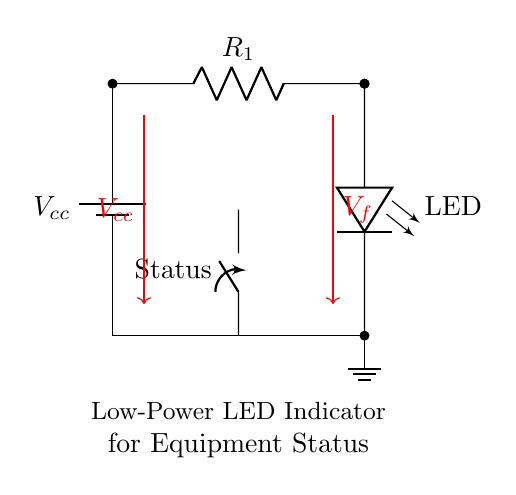What is the function of the LED in this circuit? The LED serves as an indicator for equipment status, illuminating when the circuit is active.
Answer: Indicator What component limits the current through the LED? The resistor connected in series with the LED limits the current to prevent damage to the LED.
Answer: Resistor What does the switch in this circuit represent? The switch represents a way to control whether the LED is lit or unlit by interrupting the circuit.
Answer: Status What is the voltage across the LED when it is turned on? The voltage across the LED, denoted as V_f, is typically around 2V for standard LEDs, depending on the type used.
Answer: V_f How does the current flow when the switch is closed? When the switch is closed, current flows from the battery to the resistor, then through the LED, and returns to ground, completing the circuit.
Answer: Complete What type of circuit is this diagram representing? This circuit is a simple low power LED indicator circuit designed for showing the equipment's operational status.
Answer: Low power LED indicator 